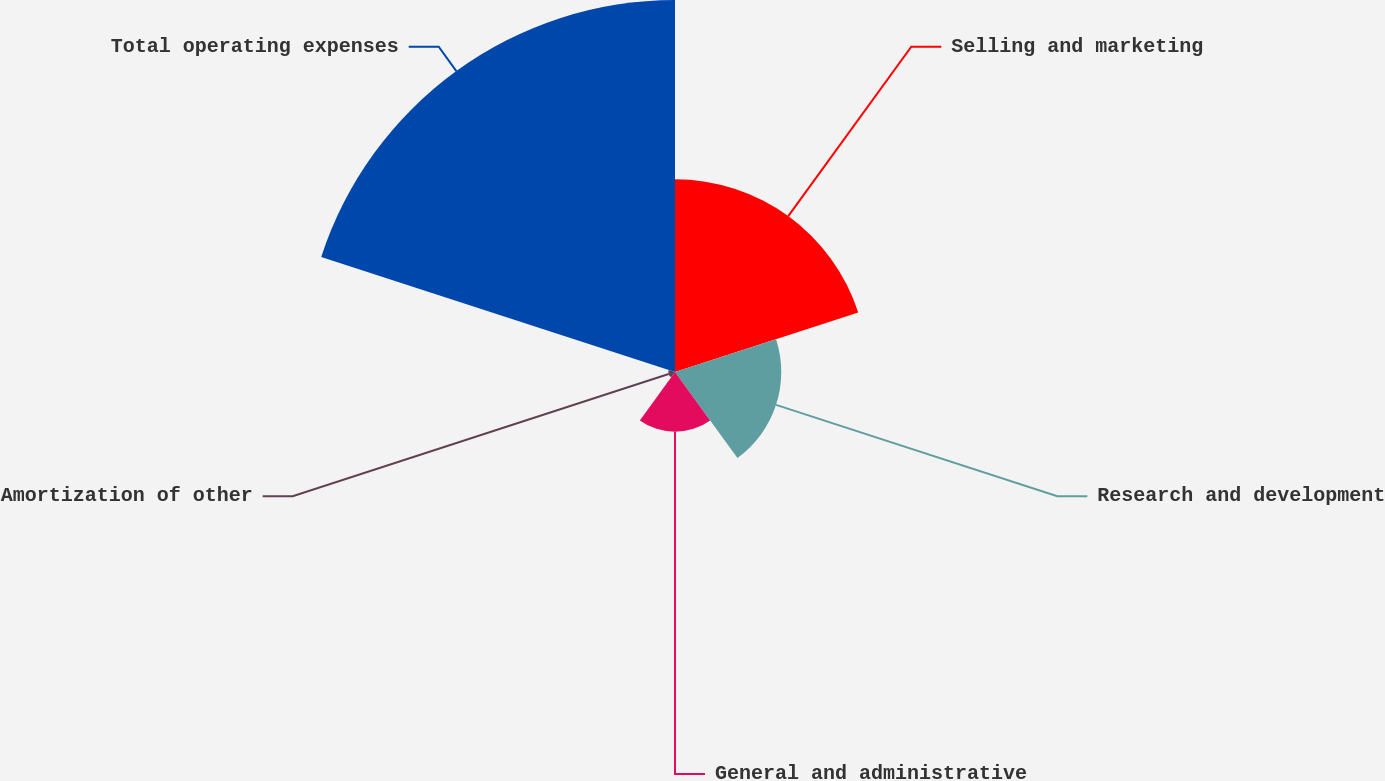<chart> <loc_0><loc_0><loc_500><loc_500><pie_chart><fcel>Selling and marketing<fcel>Research and development<fcel>General and administrative<fcel>Amortization of other<fcel>Total operating expenses<nl><fcel>26.13%<fcel>14.41%<fcel>8.11%<fcel>0.9%<fcel>50.45%<nl></chart> 